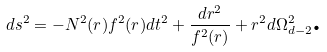Convert formula to latex. <formula><loc_0><loc_0><loc_500><loc_500>d s ^ { 2 } = - N ^ { 2 } ( r ) f ^ { 2 } ( r ) d t ^ { 2 } + \frac { d r ^ { 2 } } { f ^ { 2 } ( r ) } + r ^ { 2 } d \Omega _ { d - 2 } ^ { 2 } \text {.}</formula> 